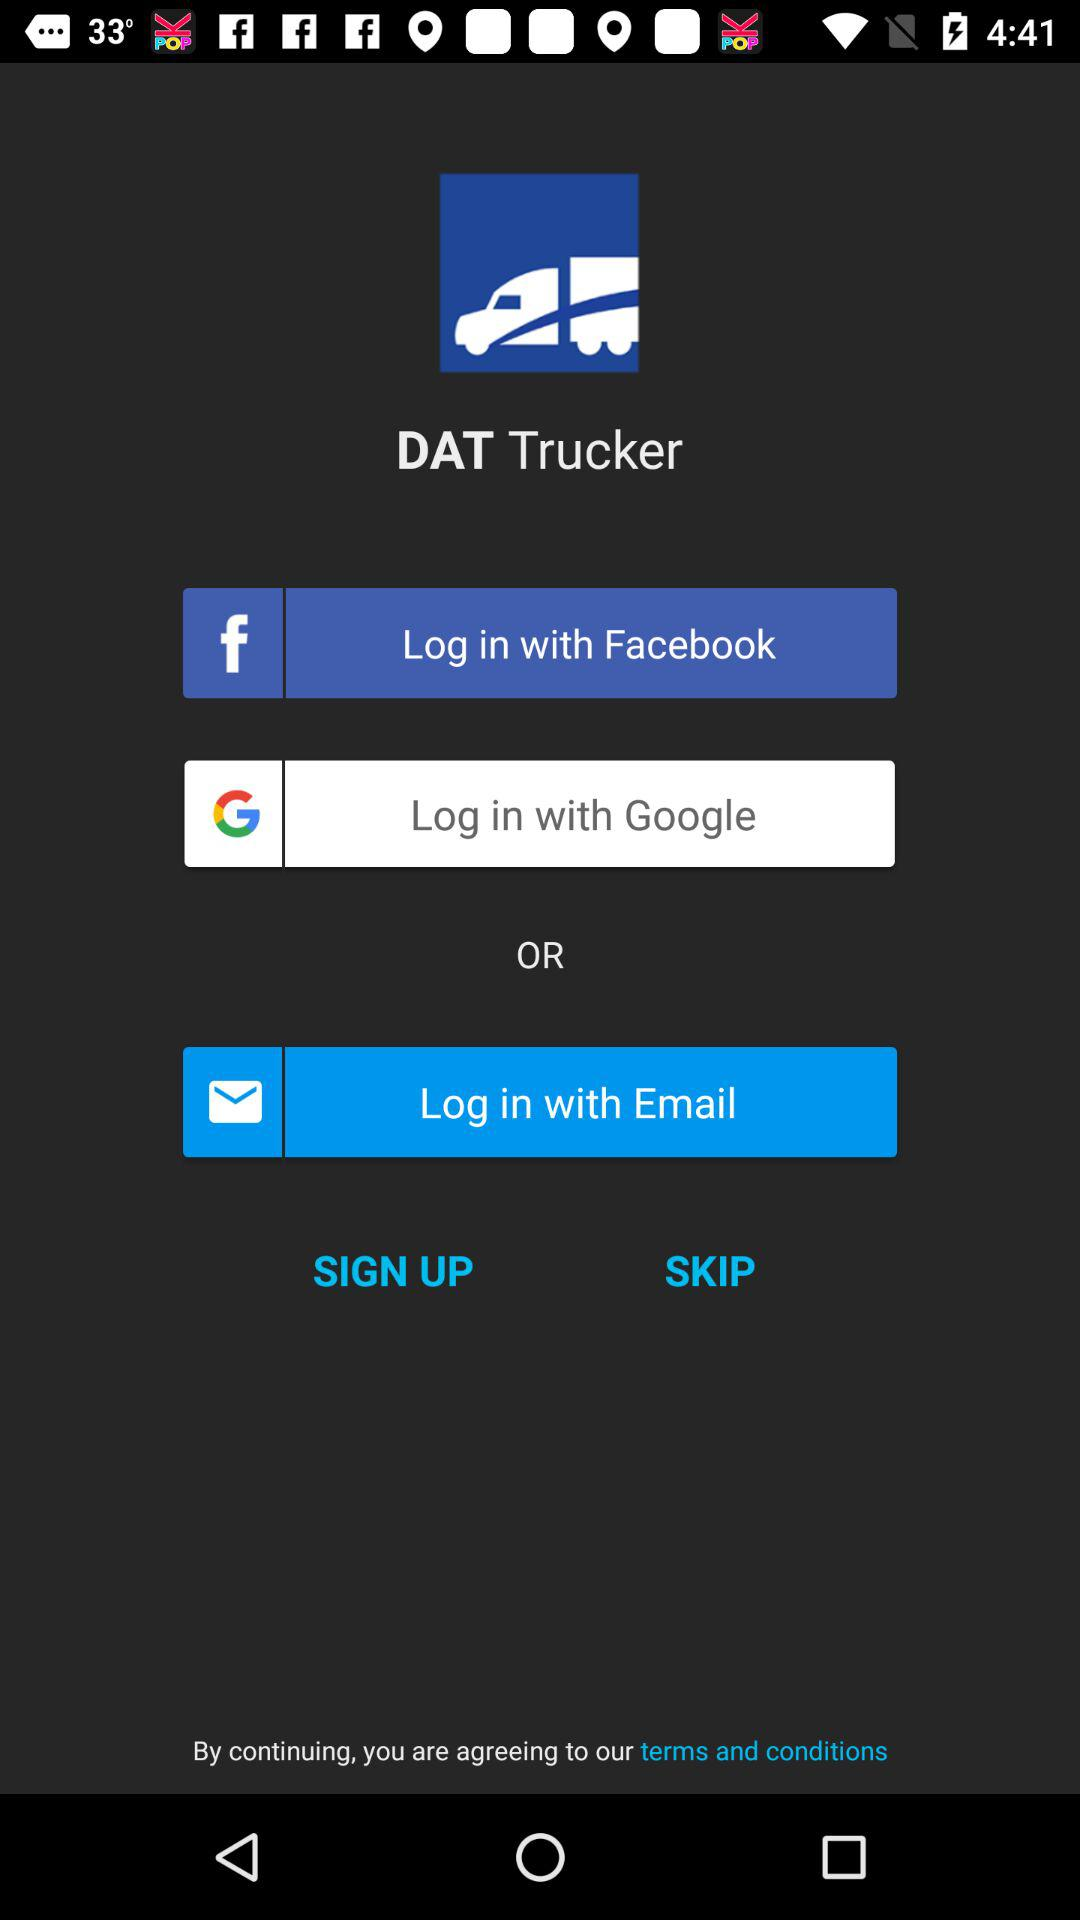What are the terms and conditions?
When the provided information is insufficient, respond with <no answer>. <no answer> 